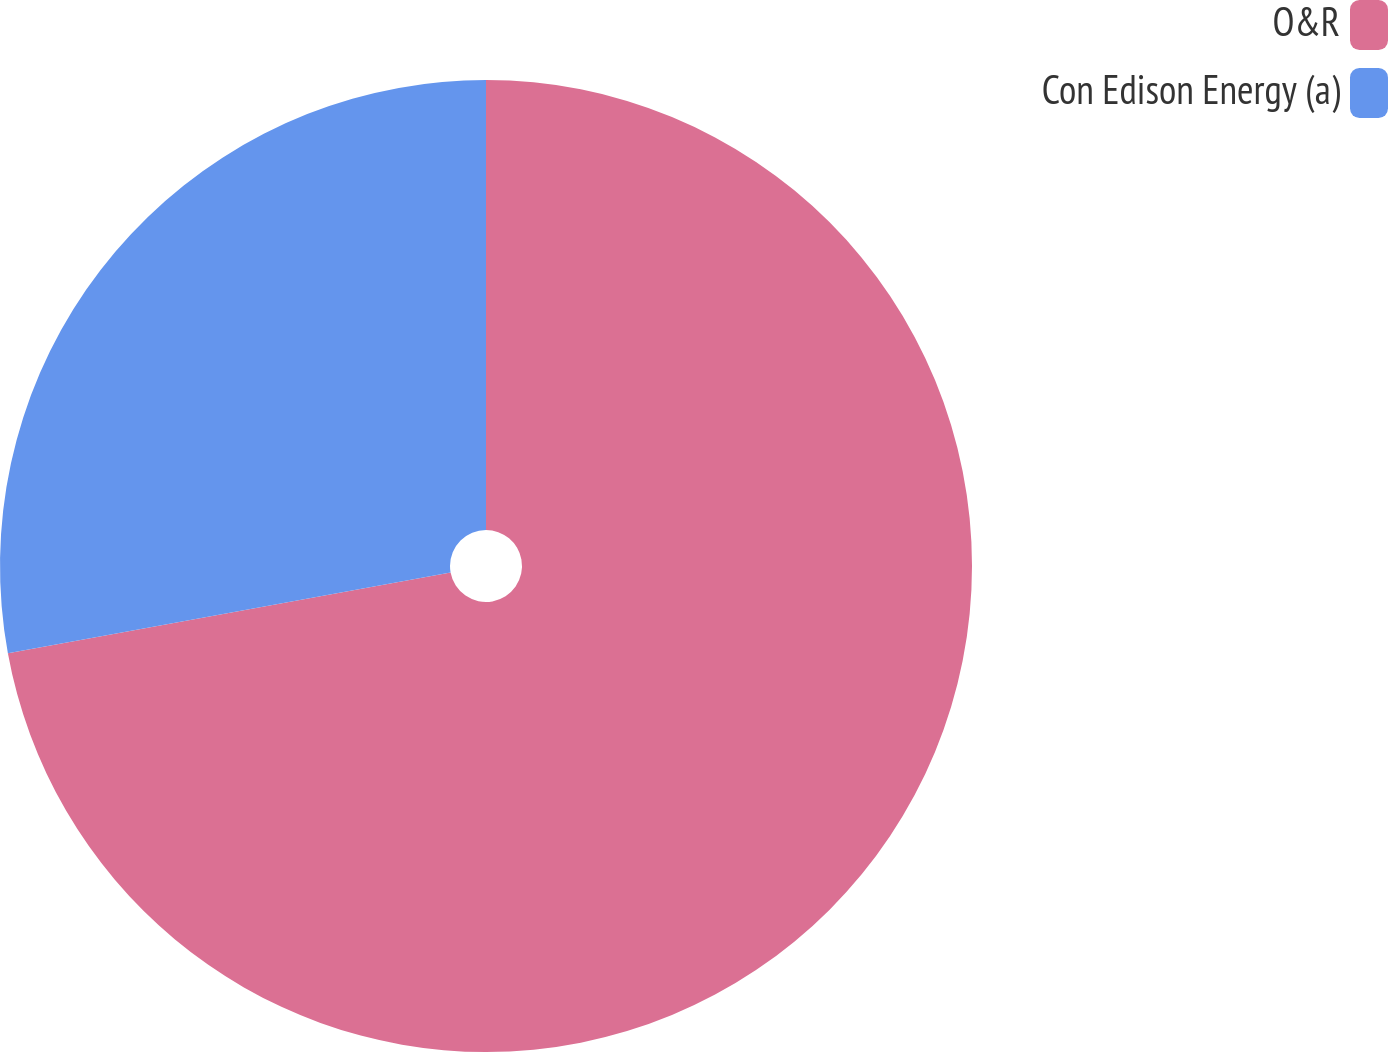<chart> <loc_0><loc_0><loc_500><loc_500><pie_chart><fcel>O&R<fcel>Con Edison Energy (a)<nl><fcel>72.13%<fcel>27.87%<nl></chart> 